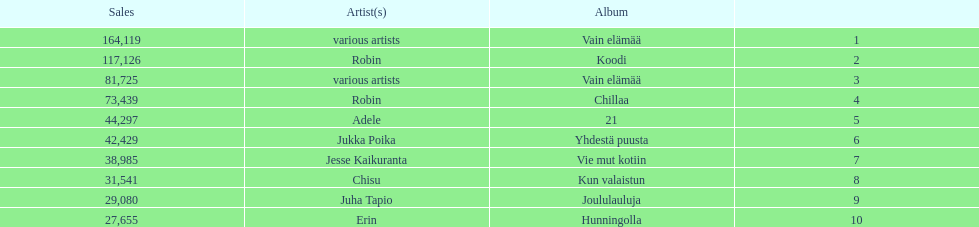Tell me what album had the most sold. Vain elämää. 